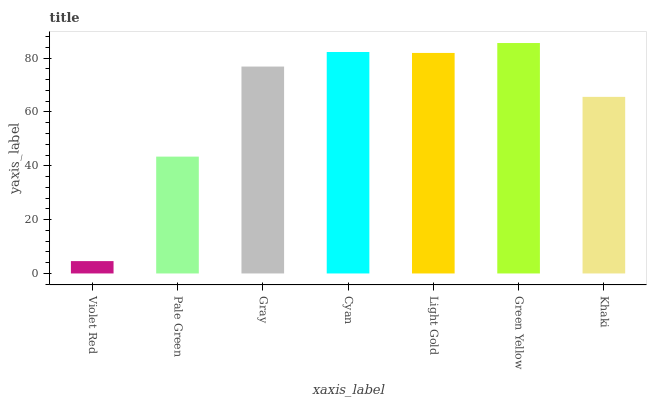Is Pale Green the minimum?
Answer yes or no. No. Is Pale Green the maximum?
Answer yes or no. No. Is Pale Green greater than Violet Red?
Answer yes or no. Yes. Is Violet Red less than Pale Green?
Answer yes or no. Yes. Is Violet Red greater than Pale Green?
Answer yes or no. No. Is Pale Green less than Violet Red?
Answer yes or no. No. Is Gray the high median?
Answer yes or no. Yes. Is Gray the low median?
Answer yes or no. Yes. Is Pale Green the high median?
Answer yes or no. No. Is Cyan the low median?
Answer yes or no. No. 